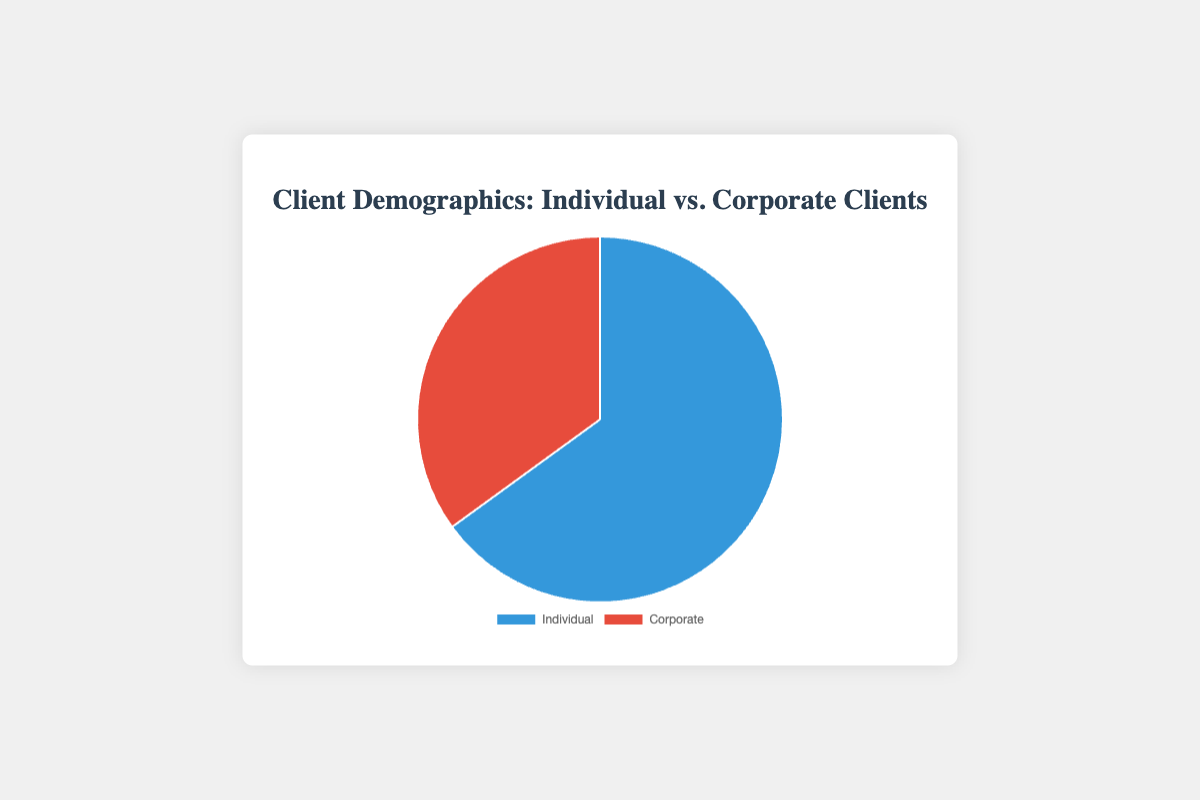What percentage of clients are Individual? According to the pie chart, there are two segments labeled "Individual" and "Corporate." The "Individual" segment shows a value of 65%.
Answer: 65% What is the difference in percentage between Individual and Corporate clients? The pie chart segments show values of 65% for Individual clients and 35% for Corporate clients. The difference is calculated as 65% - 35% = 30%.
Answer: 30% Which client type has the larger percentage? The pie chart displays two segments: "Individual" at 65% and "Corporate" at 35%. Clearly, 65% is larger than 35%.
Answer: Individual What are the colors used to represent Individual and Corporate clients? The pie chart uses blue to represent "Individual" clients and red to represent "Corporate" clients. Visually, a viewer can see that blue is associated with "Individual" and red with "Corporate."
Answer: Blue for Individual, Red for Corporate If the number of Individual clients is 130, how many Corporate clients are there? We know that 65% of clients are Individual, and 35% are Corporate. Given that 130 clients represent 65%, we can set up the equation: 130 = 0.65 * Total_clients. Solving for Total_clients gives us Total_clients = 130 / 0.65 = 200. Therefore, Corporate clients are 35% of 200, which is 0.35 * 200 = 70.
Answer: 70 How much larger is the percentage of Individual clients compared to Corporate clients? From the pie chart, Individual clients are 65% and Corporate clients are 35%. 
The difference is calculated as 65% - 35% = 30%.
Answer: 30% Which client type does the red section of the pie chart represent? The pie chart clearly shows the red section labeled as "Corporate."
Answer: Corporate If the law firm wants to achieve an equal number of Individual and Corporate clients, by what percentage should they increase Corporate clients? Starting from the existing percentages, we have 65% Individual and 35% Corporate clients. To make them equal, we need both sections to be 50%. 
Current Corporate percentage = 35%, Target Corporate percentage = 50%. 
Increase needed = 50% - 35% = 15%. 
To find the percentage increase based on the current Corporate percentage: 
Percentage Increase = (Increase needed / Current Corporate percentage) * 100 
Percentage Increase = (15 / 35) * 100 ≈ 42.86%
Answer: ≈ 42.86% 